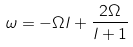<formula> <loc_0><loc_0><loc_500><loc_500>\omega = - \Omega l + \frac { 2 \Omega } { l + 1 }</formula> 